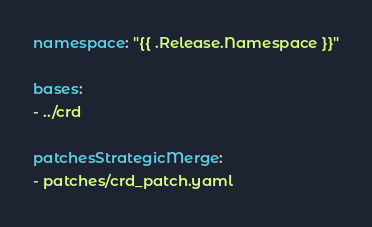Convert code to text. <code><loc_0><loc_0><loc_500><loc_500><_YAML_>namespace: "{{ .Release.Namespace }}"

bases:
- ../crd

patchesStrategicMerge:
- patches/crd_patch.yaml
</code> 